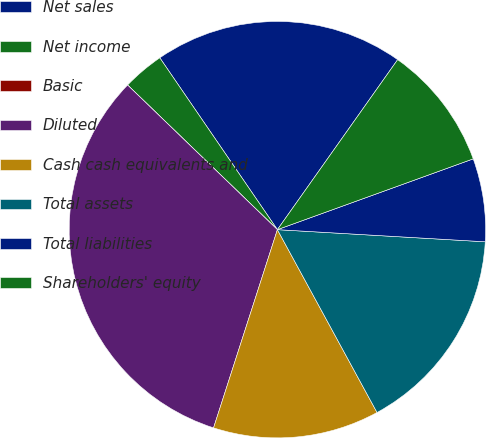<chart> <loc_0><loc_0><loc_500><loc_500><pie_chart><fcel>Net sales<fcel>Net income<fcel>Basic<fcel>Diluted<fcel>Cash cash equivalents and<fcel>Total assets<fcel>Total liabilities<fcel>Shareholders' equity<nl><fcel>19.35%<fcel>3.23%<fcel>0.0%<fcel>32.26%<fcel>12.9%<fcel>16.13%<fcel>6.45%<fcel>9.68%<nl></chart> 